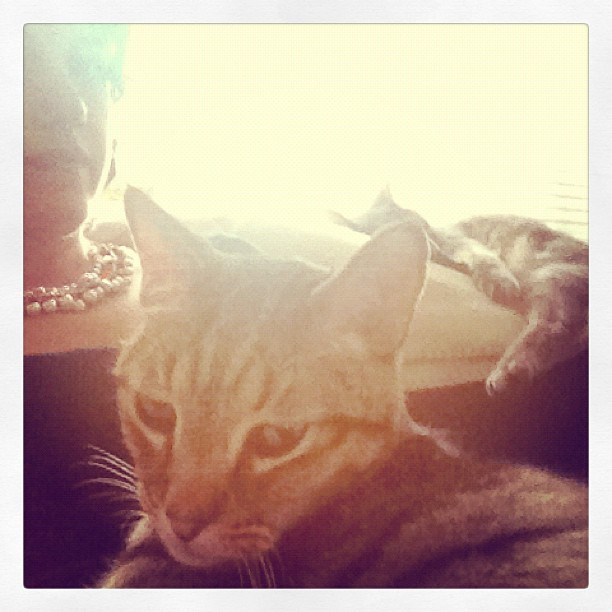<image>Why is the cat moody? I don't know why the cat is moody. It could be because it's tired or doesn't like petting. Why is the cat moody? I don't know why the cat is moody. It can be because it is bored, tired or doesn't like petting. 